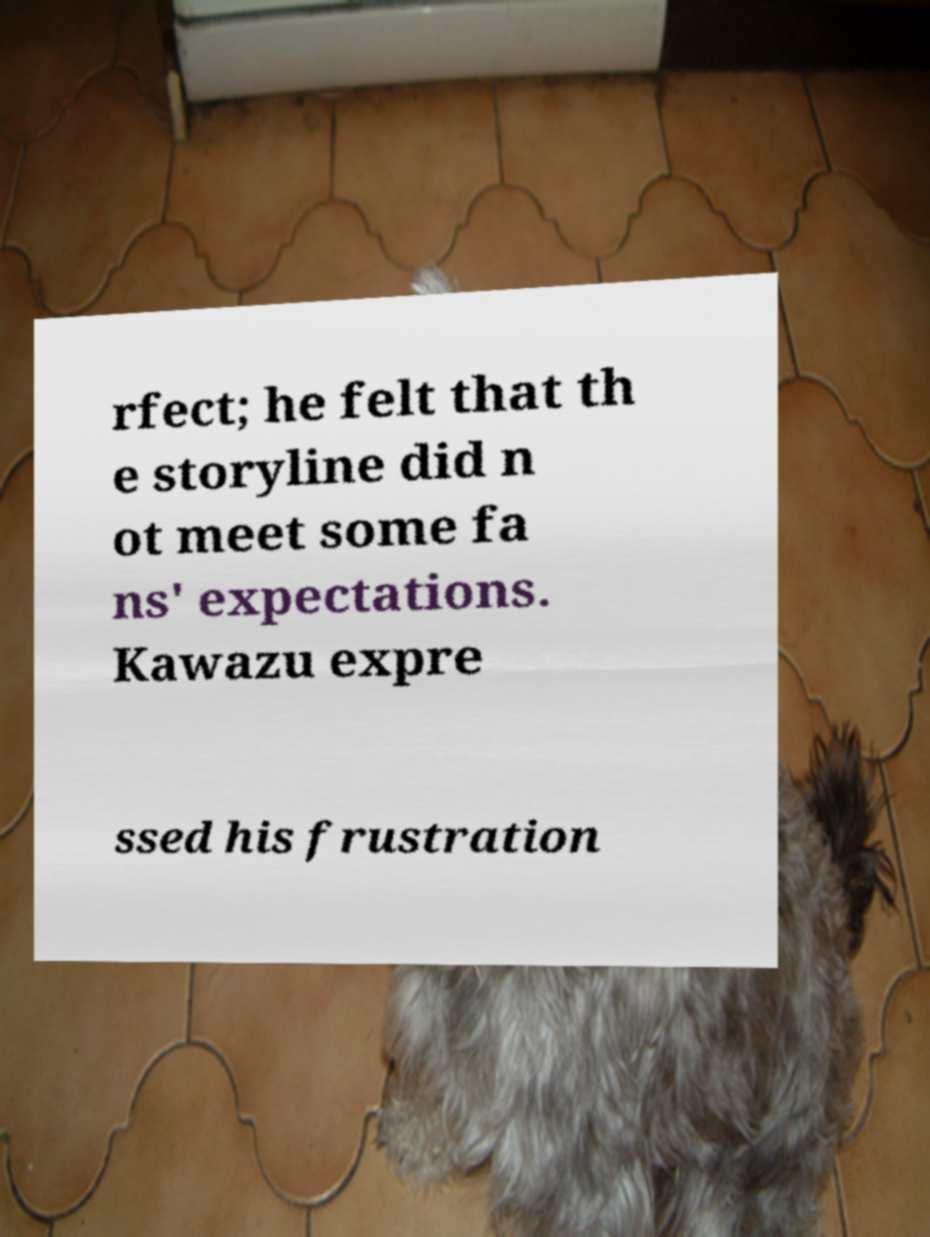Please identify and transcribe the text found in this image. rfect; he felt that th e storyline did n ot meet some fa ns' expectations. Kawazu expre ssed his frustration 